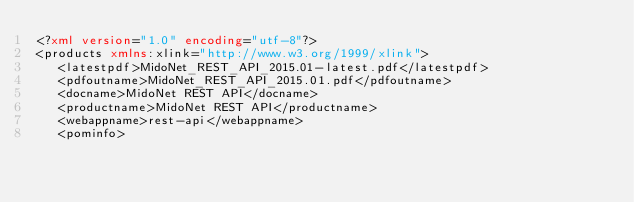<code> <loc_0><loc_0><loc_500><loc_500><_XML_><?xml version="1.0" encoding="utf-8"?>
<products xmlns:xlink="http://www.w3.org/1999/xlink">
   <latestpdf>MidoNet_REST_API_2015.01-latest.pdf</latestpdf>
   <pdfoutname>MidoNet_REST_API_2015.01.pdf</pdfoutname>
   <docname>MidoNet REST API</docname>
   <productname>MidoNet REST API</productname>
   <webappname>rest-api</webappname>
   <pominfo></code> 